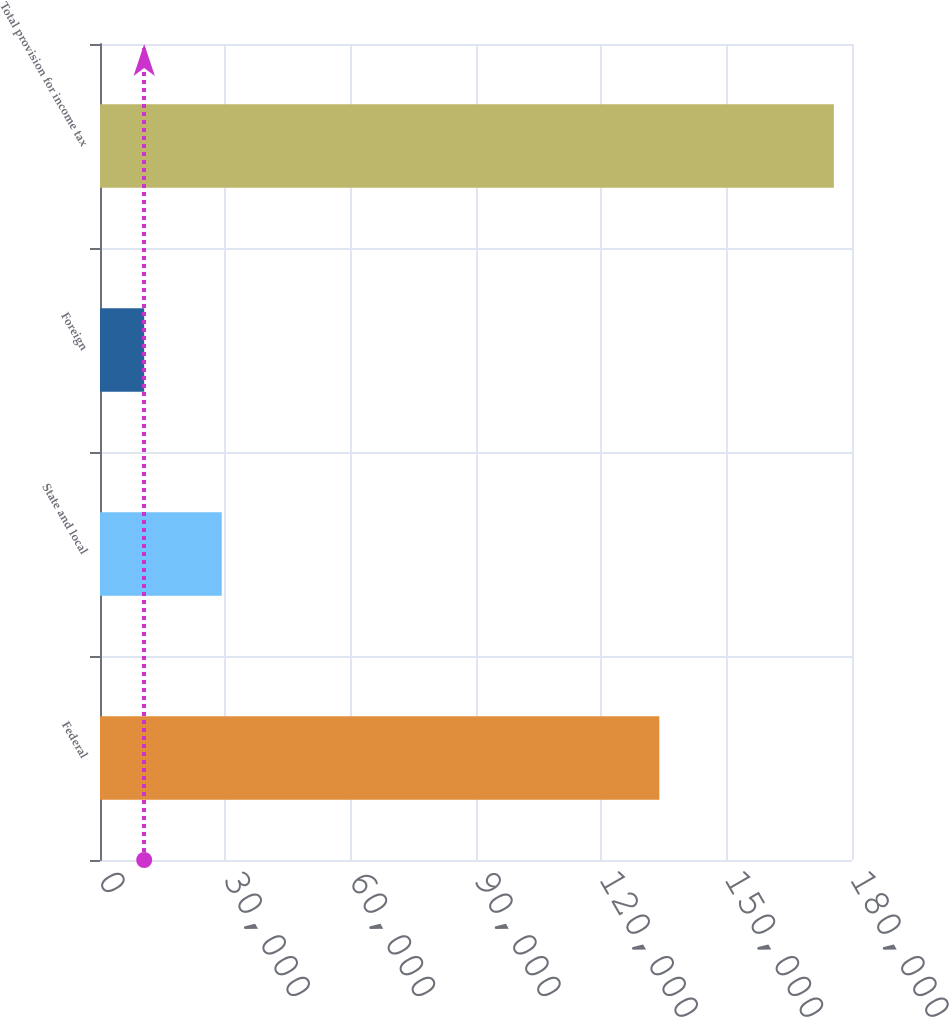<chart> <loc_0><loc_0><loc_500><loc_500><bar_chart><fcel>Federal<fcel>State and local<fcel>Foreign<fcel>Total provision for income tax<nl><fcel>133890<fcel>29141<fcel>10581<fcel>175656<nl></chart> 